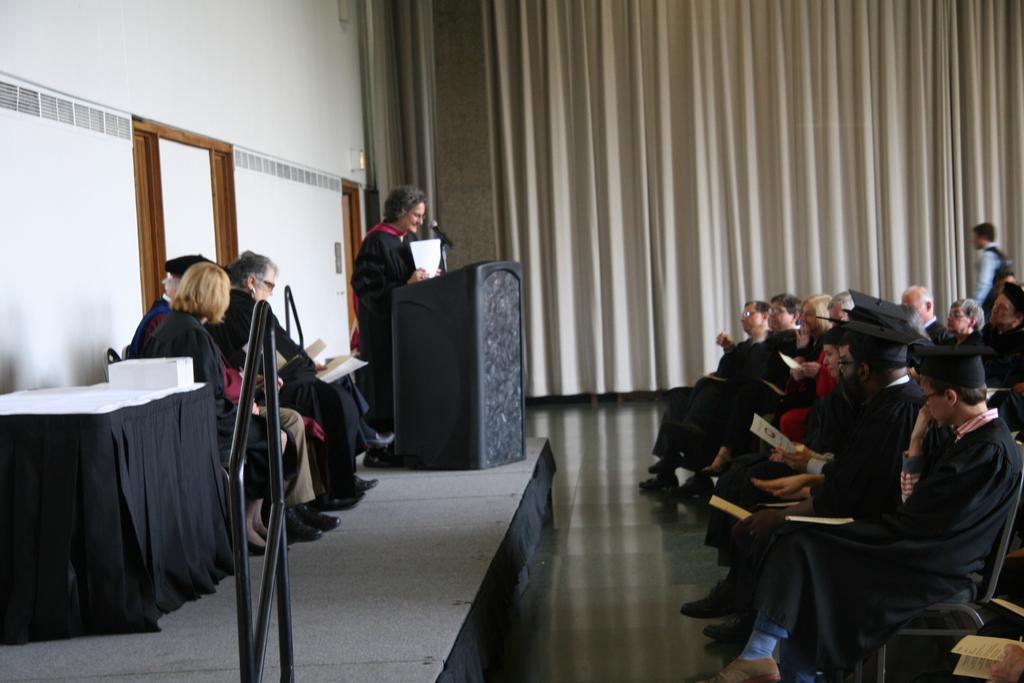Please provide a concise description of this image. In the image we can see there are people sitting and some of them are standing, they are wearing clothes and shoes. Here we can see the podium, microphone and the table, on the table we can see the box. Here we can see floor, curtains and the wall. Some people are holding papers in their hands. 